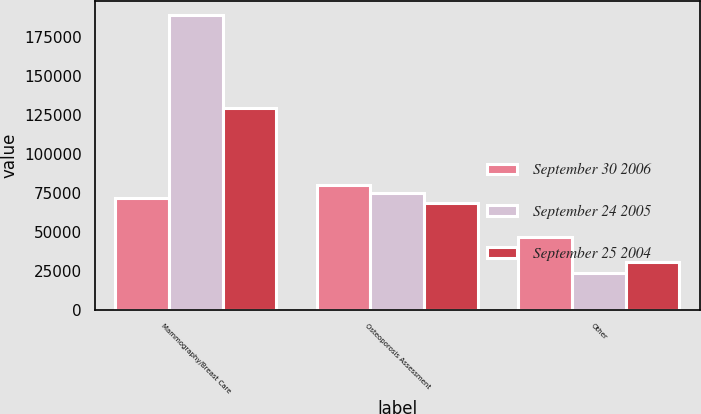Convert chart to OTSL. <chart><loc_0><loc_0><loc_500><loc_500><stacked_bar_chart><ecel><fcel>Mammography/Breast Care<fcel>Osteoporosis Assessment<fcel>Other<nl><fcel>September 30 2006<fcel>71720<fcel>80162<fcel>46723<nl><fcel>September 24 2005<fcel>189313<fcel>74957<fcel>23414<nl><fcel>September 25 2004<fcel>129626<fcel>68483<fcel>30596<nl></chart> 